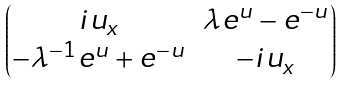Convert formula to latex. <formula><loc_0><loc_0><loc_500><loc_500>\begin{pmatrix} i u _ { x } & \lambda e ^ { u } - e ^ { - u } \\ - \lambda ^ { - 1 } e ^ { u } + e ^ { - u } & - i u _ { x } \end{pmatrix}</formula> 